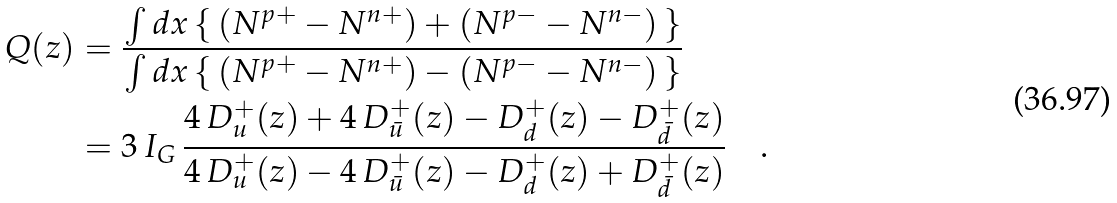Convert formula to latex. <formula><loc_0><loc_0><loc_500><loc_500>Q ( z ) & = \frac { \int d x \, \{ \, ( N ^ { p + } - N ^ { n + } ) + ( N ^ { p - } - N ^ { n - } ) \, \} } { \int d x \, \{ \, ( N ^ { p + } - N ^ { n + } ) - ( N ^ { p - } - N ^ { n - } ) \, \} } \\ & = 3 \, I _ { G } \, \frac { 4 \, D _ { u } ^ { + } ( z ) + 4 \, D _ { \bar { u } } ^ { + } ( z ) - D _ { d } ^ { + } ( z ) - D _ { \bar { d } } ^ { + } ( z ) } { 4 \, D _ { u } ^ { + } ( z ) - 4 \, D _ { \bar { u } } ^ { + } ( z ) - D _ { d } ^ { + } ( z ) + D _ { \bar { d } } ^ { + } ( z ) } \quad .</formula> 